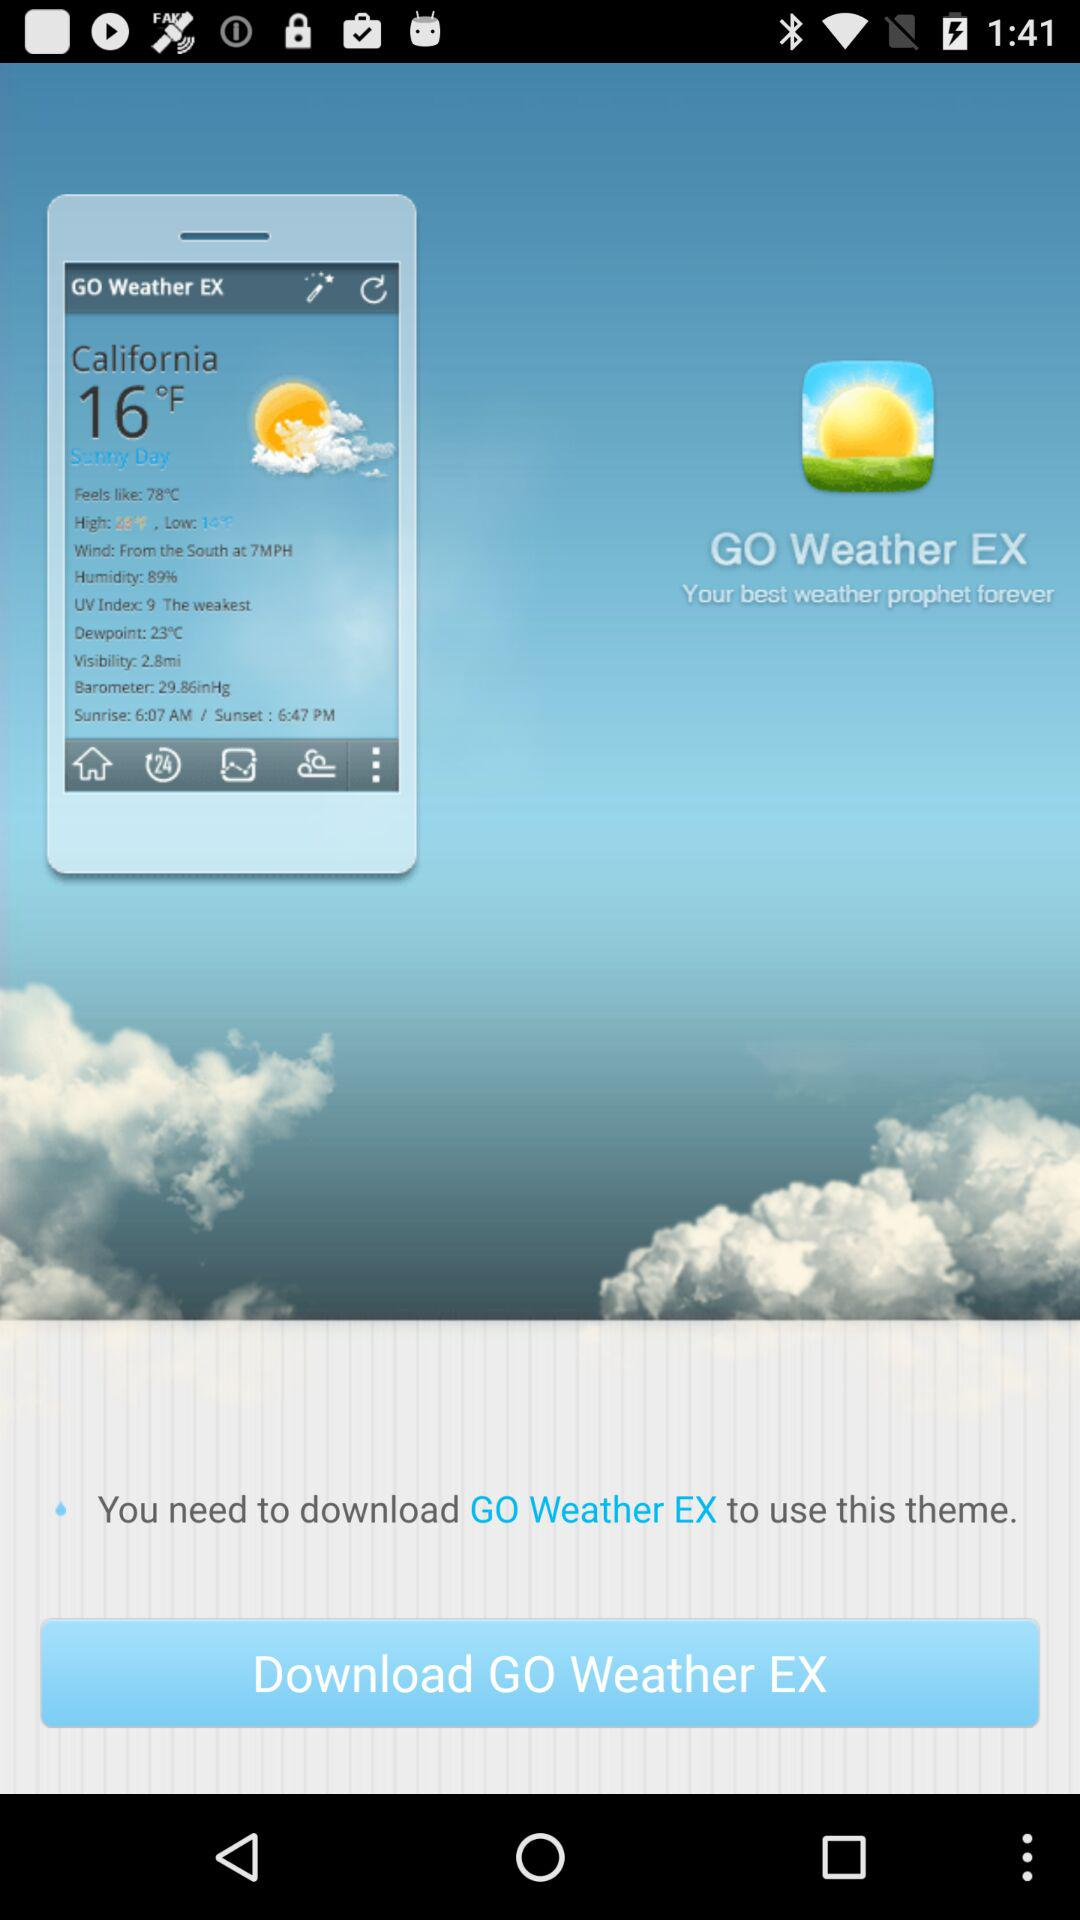What is the temperature? The temperature is 16° fahrenheit. 